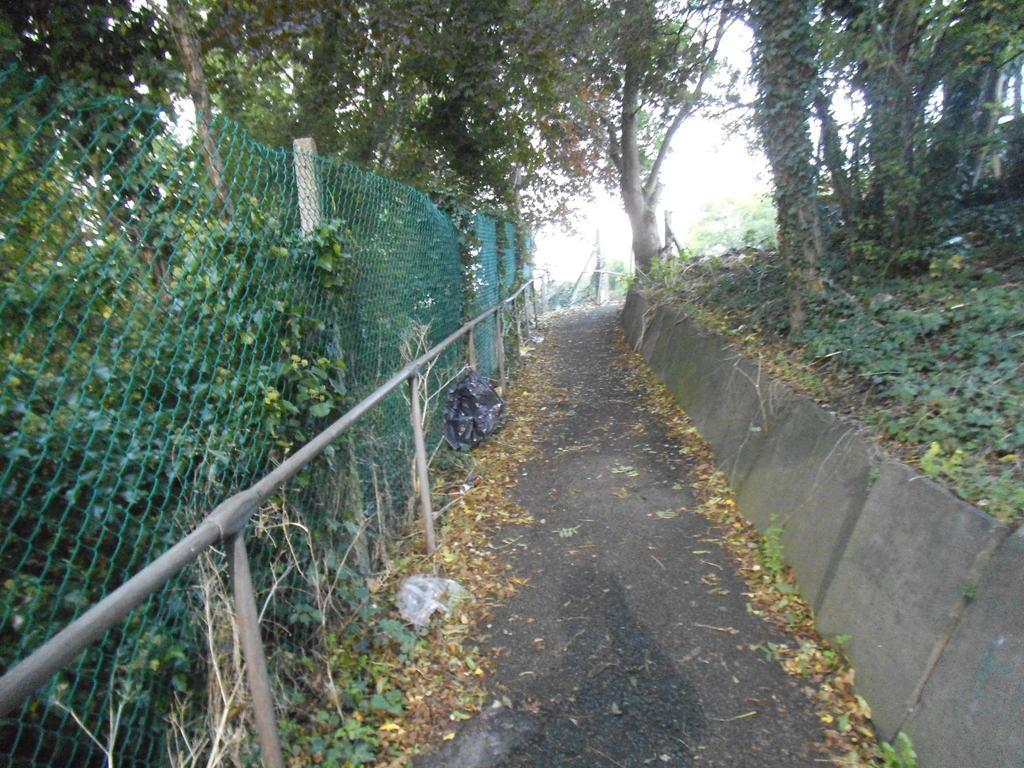Describe this image in one or two sentences. In this image I can see a road in the center and both side of it I can see number of trees and grass. On the left side of this image I can see fencing. 